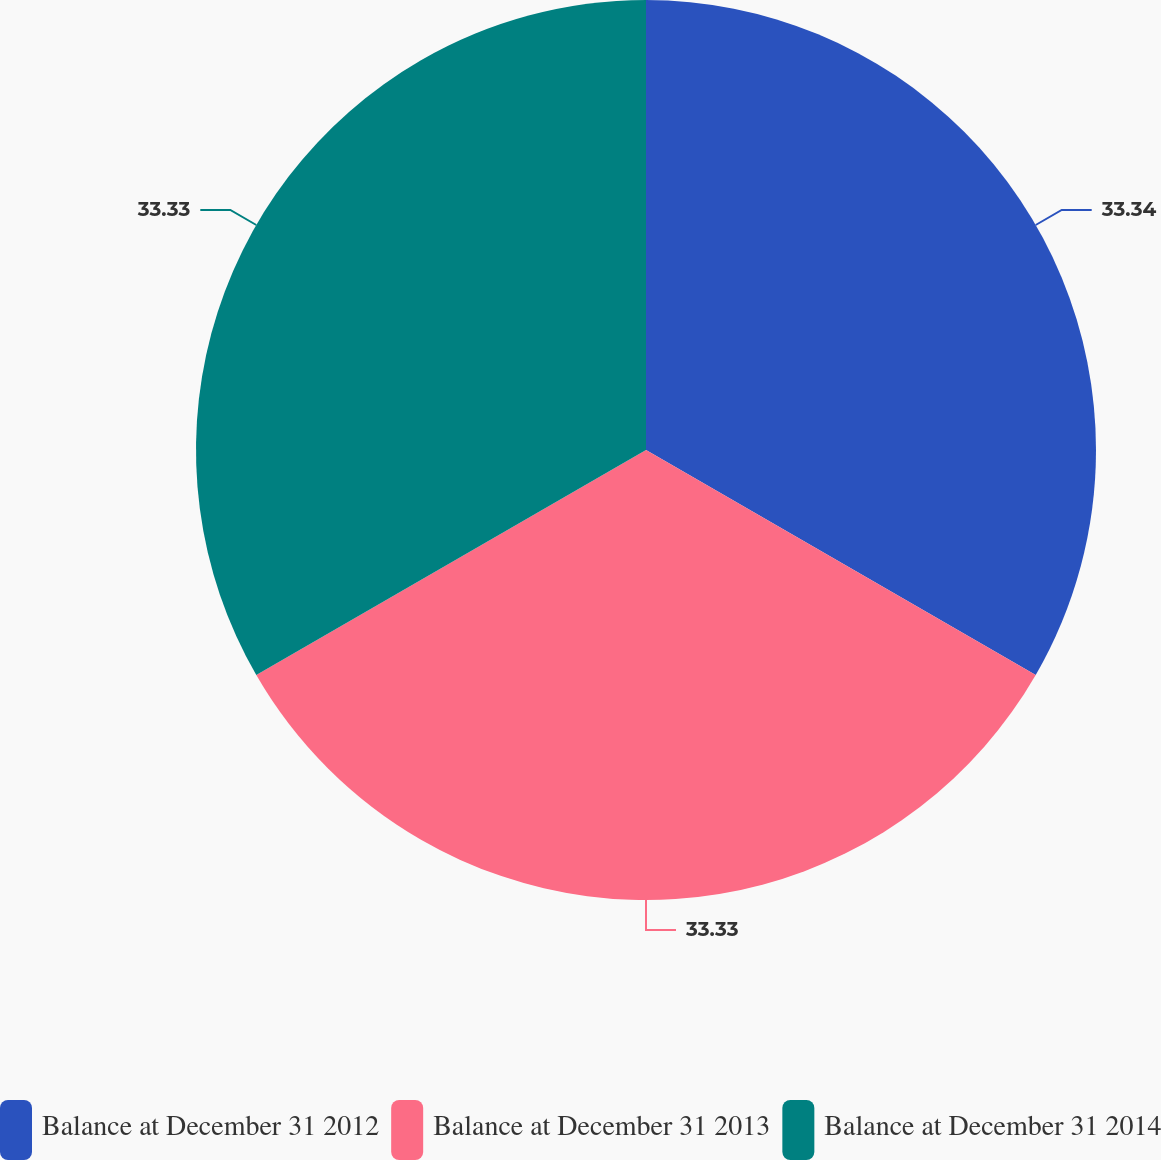<chart> <loc_0><loc_0><loc_500><loc_500><pie_chart><fcel>Balance at December 31 2012<fcel>Balance at December 31 2013<fcel>Balance at December 31 2014<nl><fcel>33.33%<fcel>33.33%<fcel>33.33%<nl></chart> 